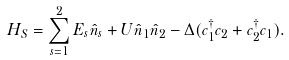<formula> <loc_0><loc_0><loc_500><loc_500>H _ { S } = \sum _ { s = 1 } ^ { 2 } E _ { s } \hat { n } _ { s } + U { \hat { n } } _ { 1 } { \hat { n } } _ { 2 } - \Delta ( c _ { 1 } ^ { \dagger } c _ { 2 } + c _ { 2 } ^ { \dagger } c _ { 1 } ) .</formula> 